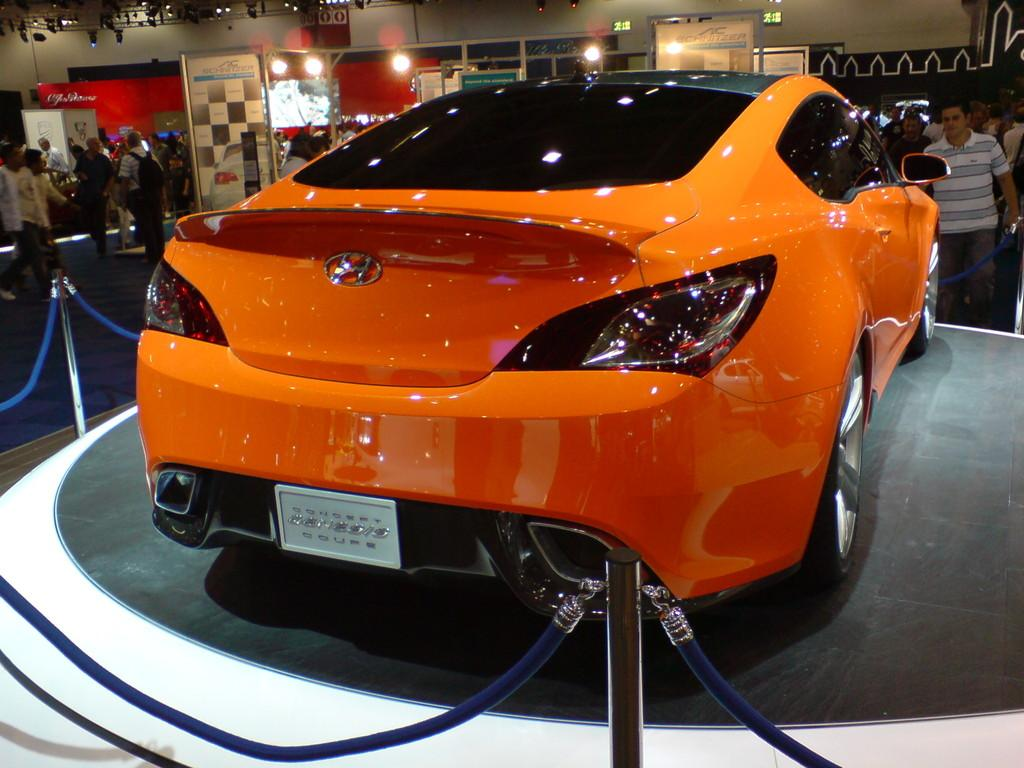What is the main subject in the center of the image? There is a car in the center of the image. Can you describe the color of the car? The car is orange in color. What can be seen in the background of the image? There are people in the background of the image. What is the purpose of the banner with text in the image? The banner with text in the image may be used for advertising or conveying information. What type of illumination is visible in the image? There are lights visible in the image. What type of writing is visible on the roof of the car in the image? There is no writing visible on the roof of the car in the image. What kind of doll is sitting on the hood of the car? There is no doll present on the car in the image. 